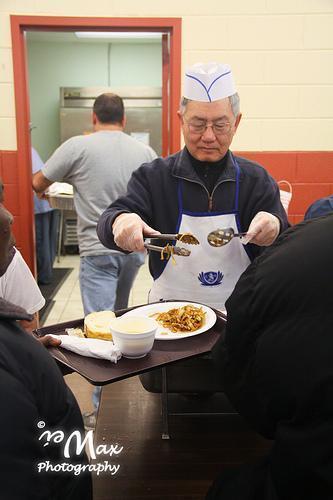How many hats is the man with an apron wearing?
Give a very brief answer. 1. 